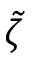Convert formula to latex. <formula><loc_0><loc_0><loc_500><loc_500>\tilde { \zeta }</formula> 